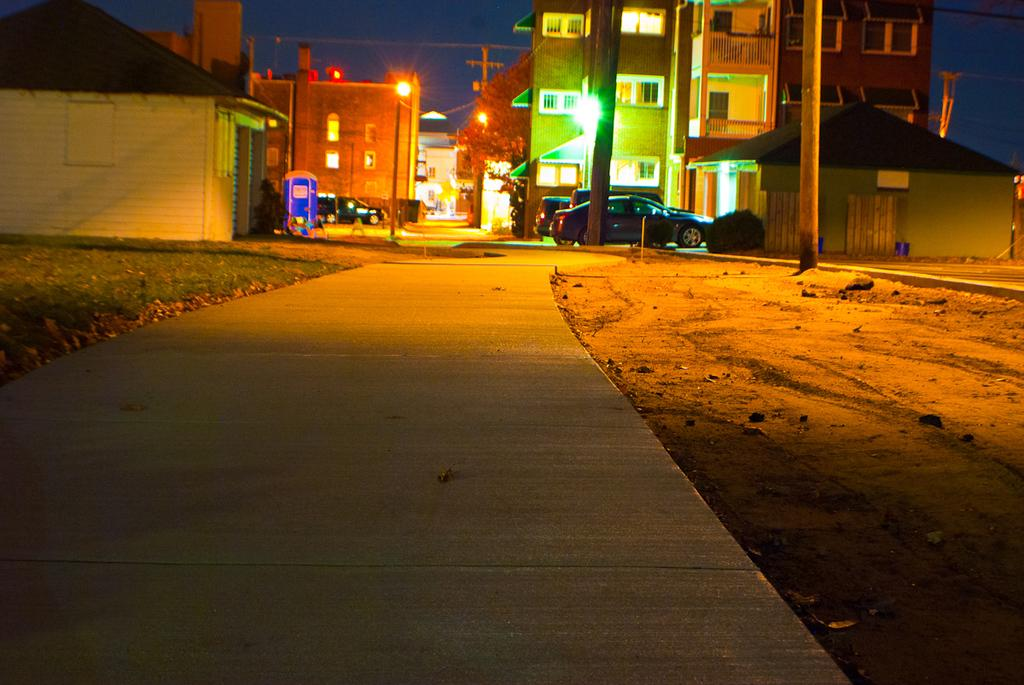What type of structures can be seen in the image? There are buildings in the image. What objects are present alongside the buildings? There are poles and lights in the image. What type of vegetation is visible in the image? There are trees in the image. What part of the natural environment is visible in the image? The sky is visible in the image. What type of transportation is present in the image? There are vehicles on the road in the image. What time of day is depicted in the image? The image is taken during night. Can you tell me how many firemen are standing near the trees in the image? There are no firemen present in the image; it features buildings, poles, lights, trees, the sky, vehicles, and is taken during night. What type of heart-shaped object can be seen in the image? There is no heart-shaped object present in the image. 